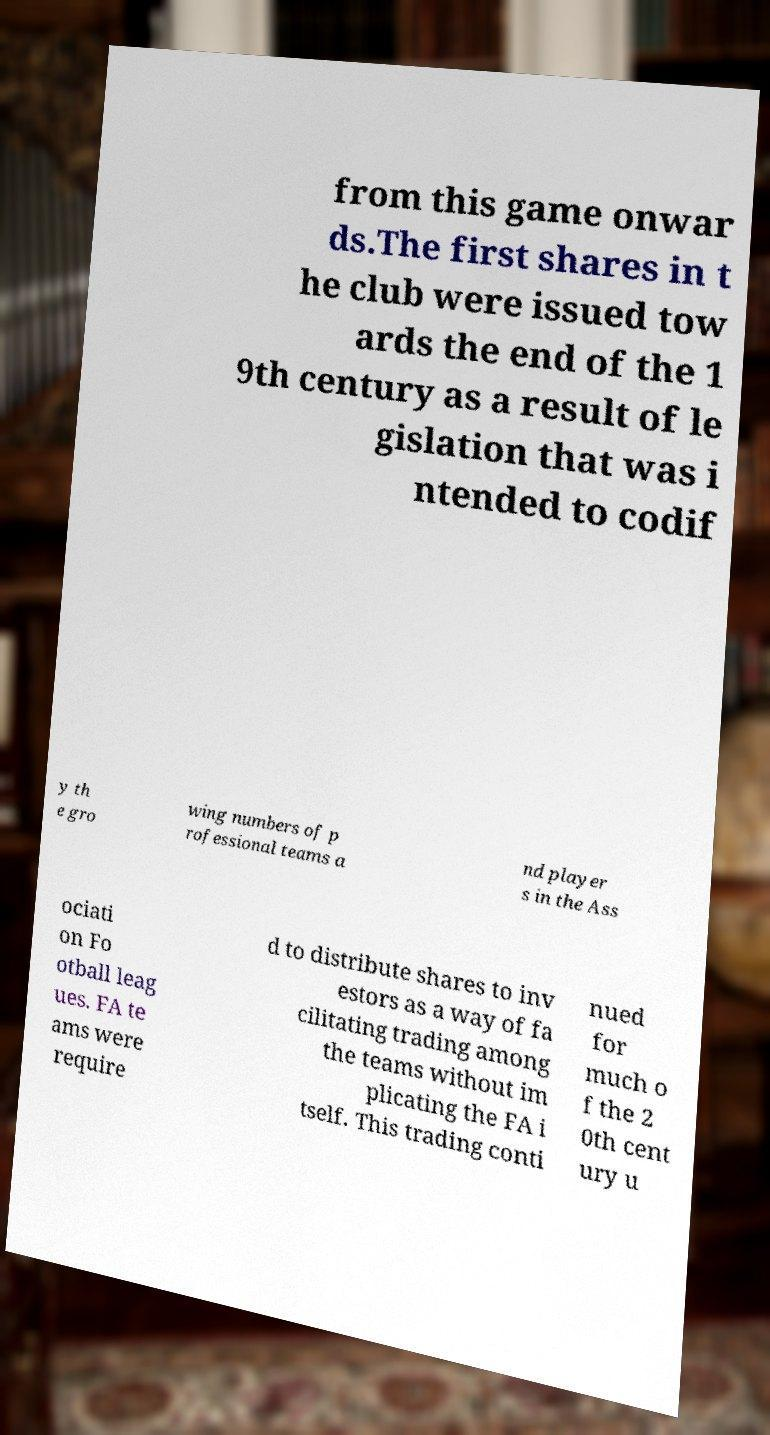Please read and relay the text visible in this image. What does it say? from this game onwar ds.The first shares in t he club were issued tow ards the end of the 1 9th century as a result of le gislation that was i ntended to codif y th e gro wing numbers of p rofessional teams a nd player s in the Ass ociati on Fo otball leag ues. FA te ams were require d to distribute shares to inv estors as a way of fa cilitating trading among the teams without im plicating the FA i tself. This trading conti nued for much o f the 2 0th cent ury u 